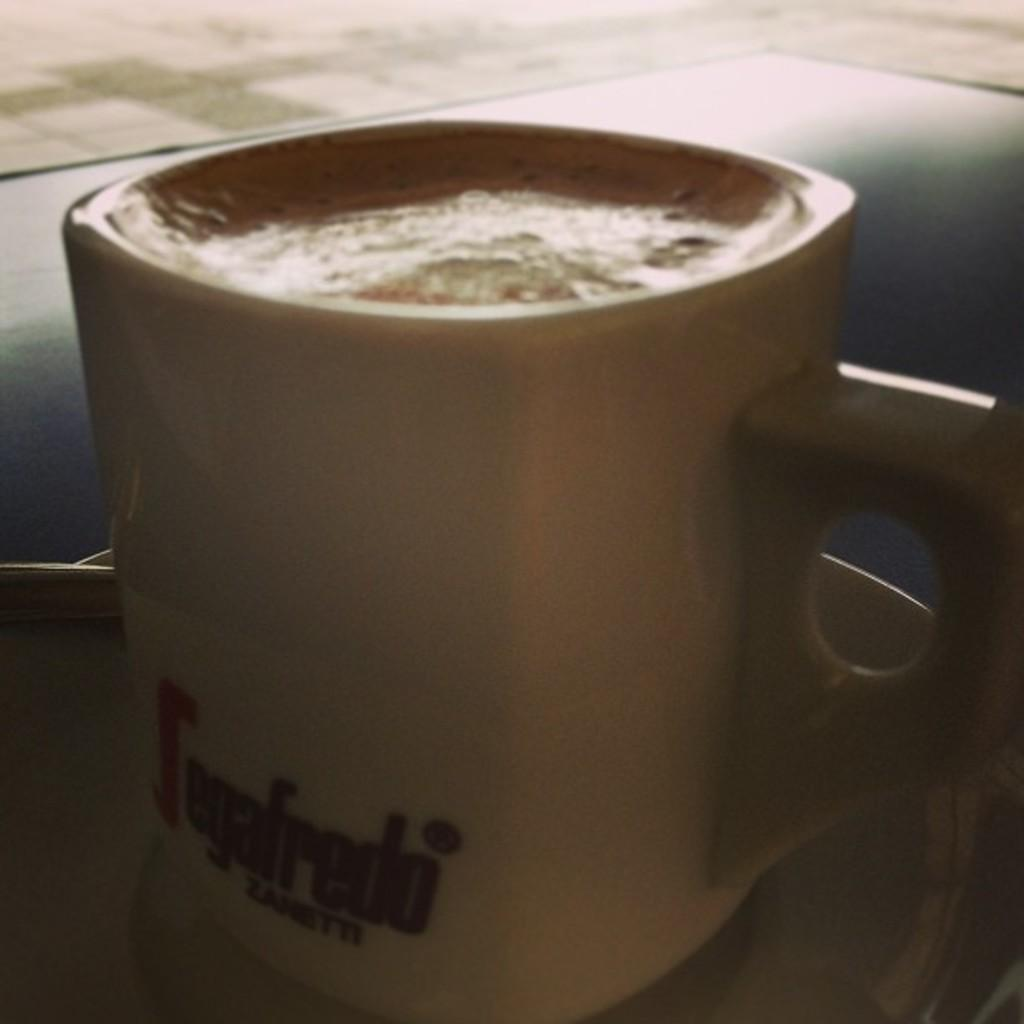What is in the cup that is visible in the image? The cup contains coffee. What is the cup placed on in the image? The cup is on a surface. What type of butter is being used to cause a reaction in the image? There is no butter or reaction present in the image. 